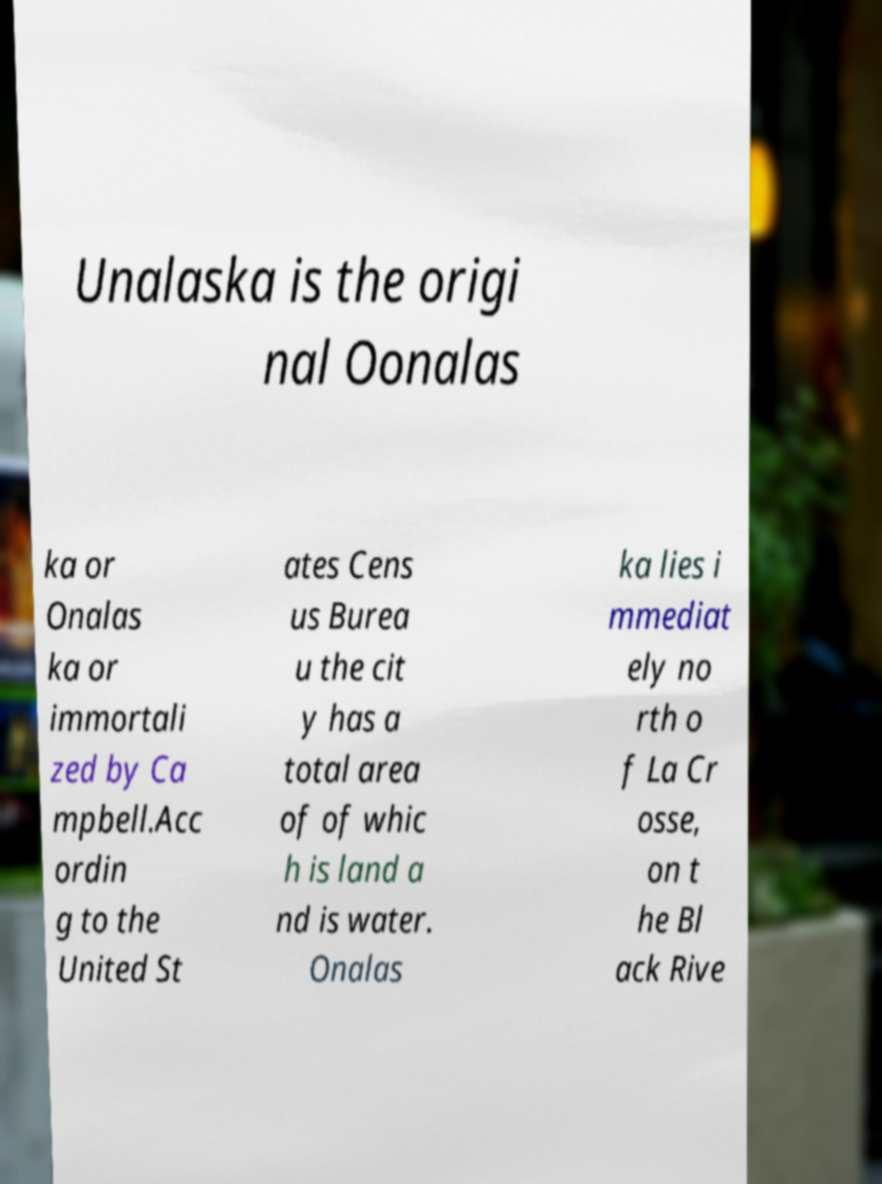There's text embedded in this image that I need extracted. Can you transcribe it verbatim? Unalaska is the origi nal Oonalas ka or Onalas ka or immortali zed by Ca mpbell.Acc ordin g to the United St ates Cens us Burea u the cit y has a total area of of whic h is land a nd is water. Onalas ka lies i mmediat ely no rth o f La Cr osse, on t he Bl ack Rive 